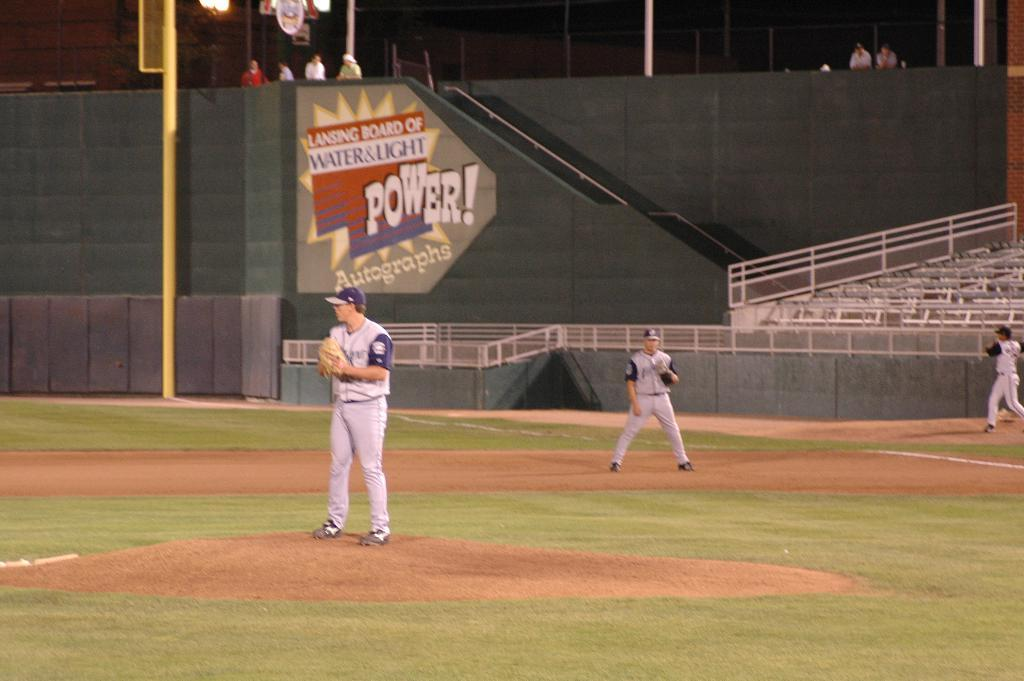Provide a one-sentence caption for the provided image. A pitcher on the mound of a baseball field in front of a green wall with a sign for Power! photographs. 